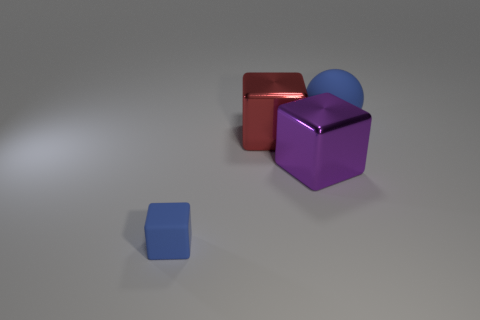Subtract all red blocks. Subtract all large purple objects. How many objects are left? 2 Add 4 large cubes. How many large cubes are left? 6 Add 3 large red metallic objects. How many large red metallic objects exist? 4 Add 4 small blue rubber things. How many objects exist? 8 Subtract all red cubes. How many cubes are left? 2 Subtract all metallic blocks. How many blocks are left? 1 Subtract 0 gray balls. How many objects are left? 4 Subtract all blocks. How many objects are left? 1 Subtract 3 cubes. How many cubes are left? 0 Subtract all green cubes. Subtract all gray cylinders. How many cubes are left? 3 